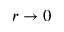Convert formula to latex. <formula><loc_0><loc_0><loc_500><loc_500>r \rightarrow 0</formula> 